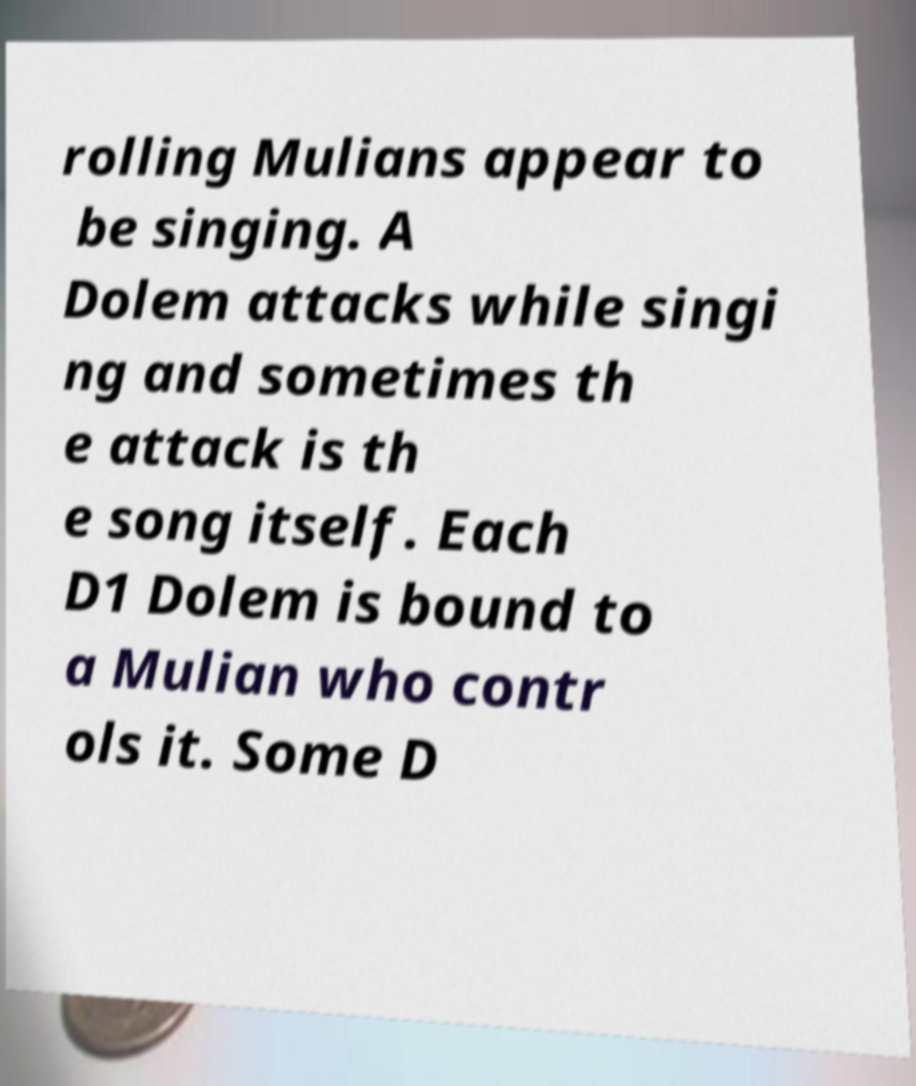Can you read and provide the text displayed in the image?This photo seems to have some interesting text. Can you extract and type it out for me? rolling Mulians appear to be singing. A Dolem attacks while singi ng and sometimes th e attack is th e song itself. Each D1 Dolem is bound to a Mulian who contr ols it. Some D 